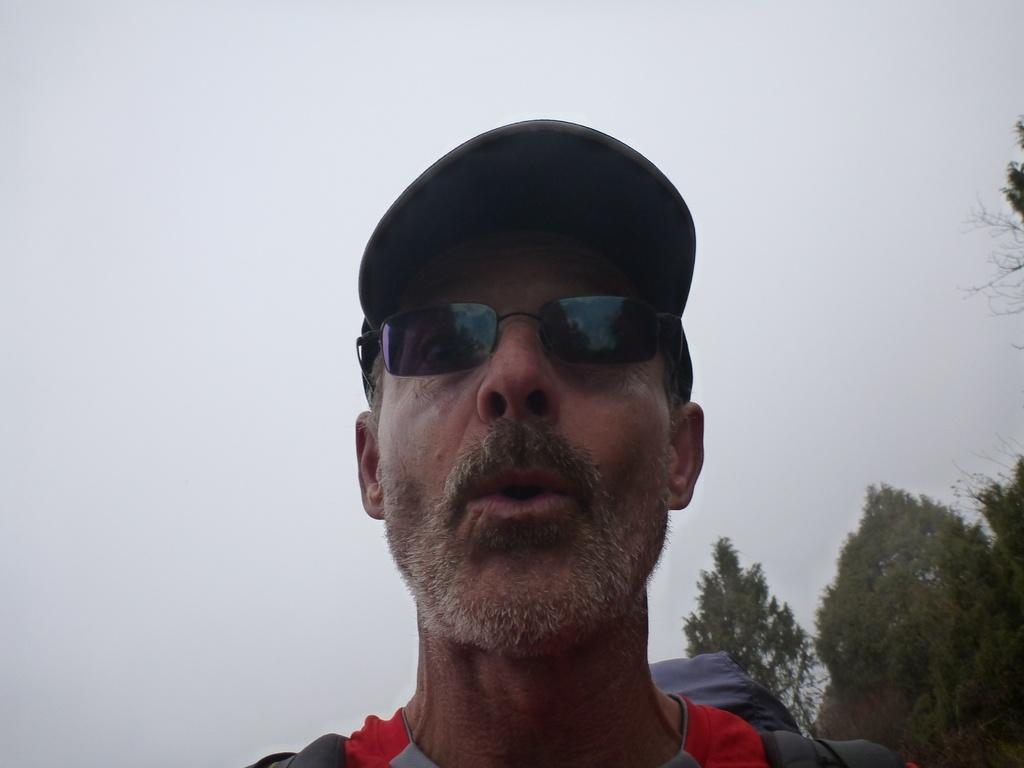Could you give a brief overview of what you see in this image? In this picture there is a man in the center of the image and there are trees in the background area of the image. 